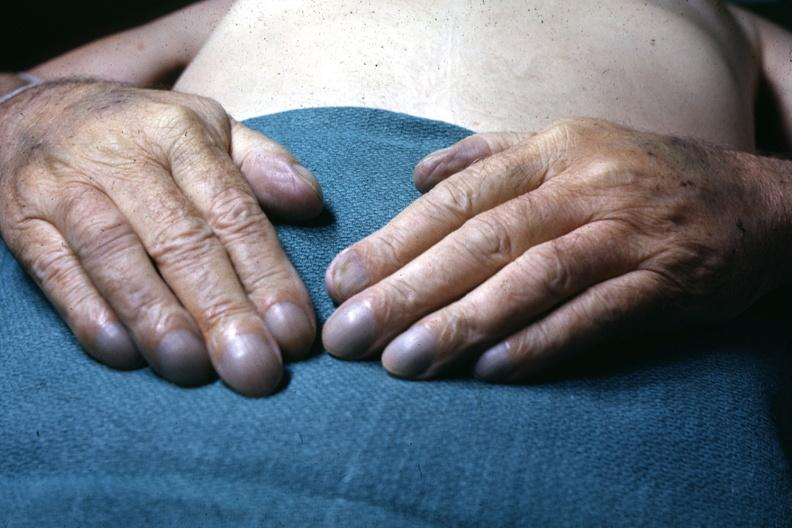re extremities present?
Answer the question using a single word or phrase. Yes 